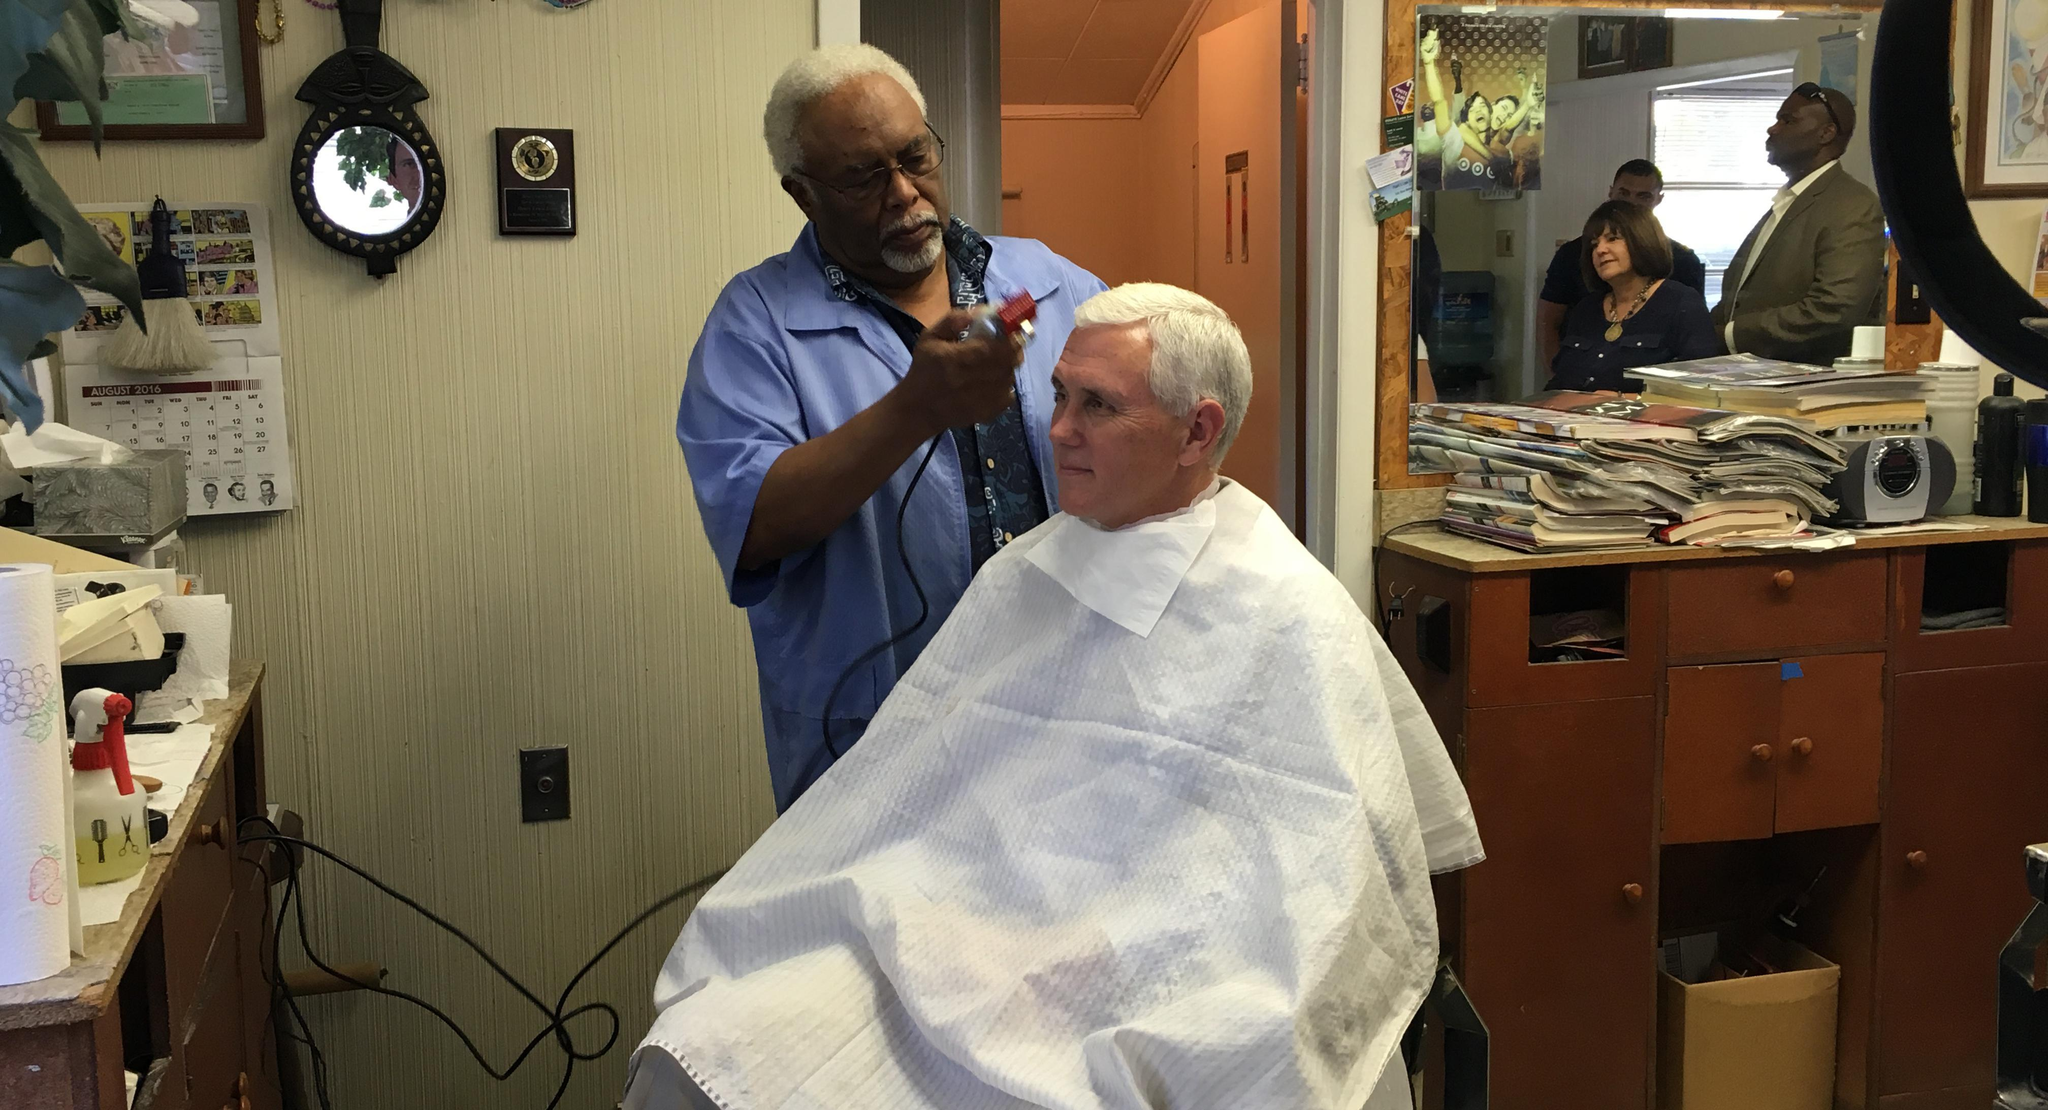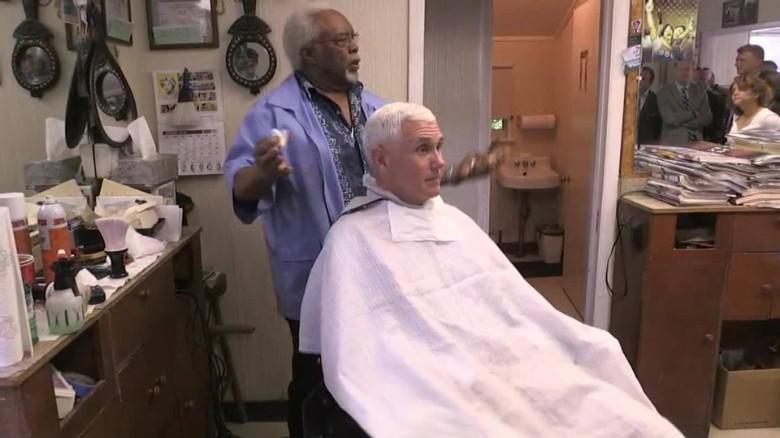The first image is the image on the left, the second image is the image on the right. Considering the images on both sides, is "The left image features a row of male customers sitting and wearing black smocks, with someone standing behind them." valid? Answer yes or no. No. The first image is the image on the left, the second image is the image on the right. Considering the images on both sides, is "In at least one image there are at least three men with black hair getting there hair cut." valid? Answer yes or no. No. 